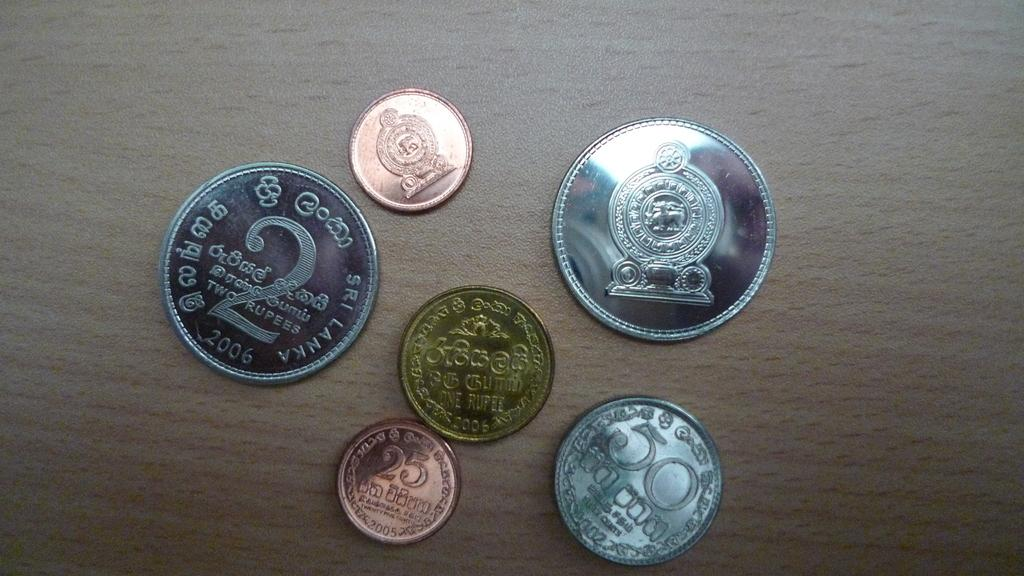Provide a one-sentence caption for the provided image. A coin with the number 2 very large on it sits next to 5 other coins. 